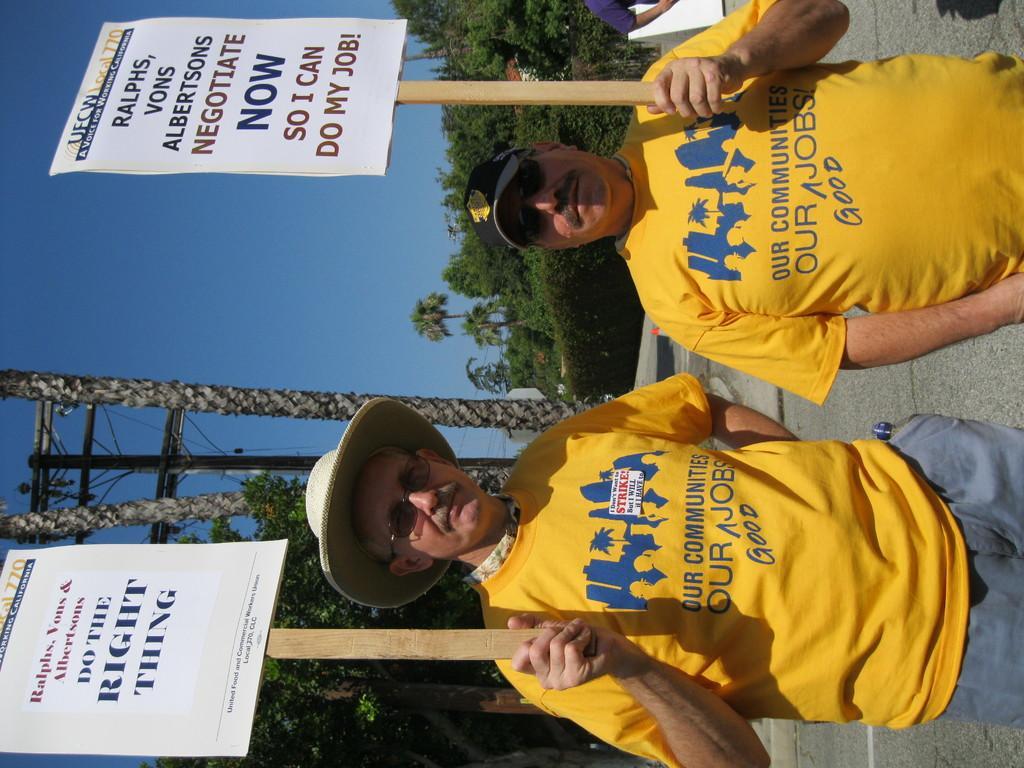In one or two sentences, can you explain what this image depicts? In this picture we can see two men wore caps, goggles and holding posters with their hands and at the back of them we can see a person's hand, trees, electric pole and some objects and in the background we can see the sky. 